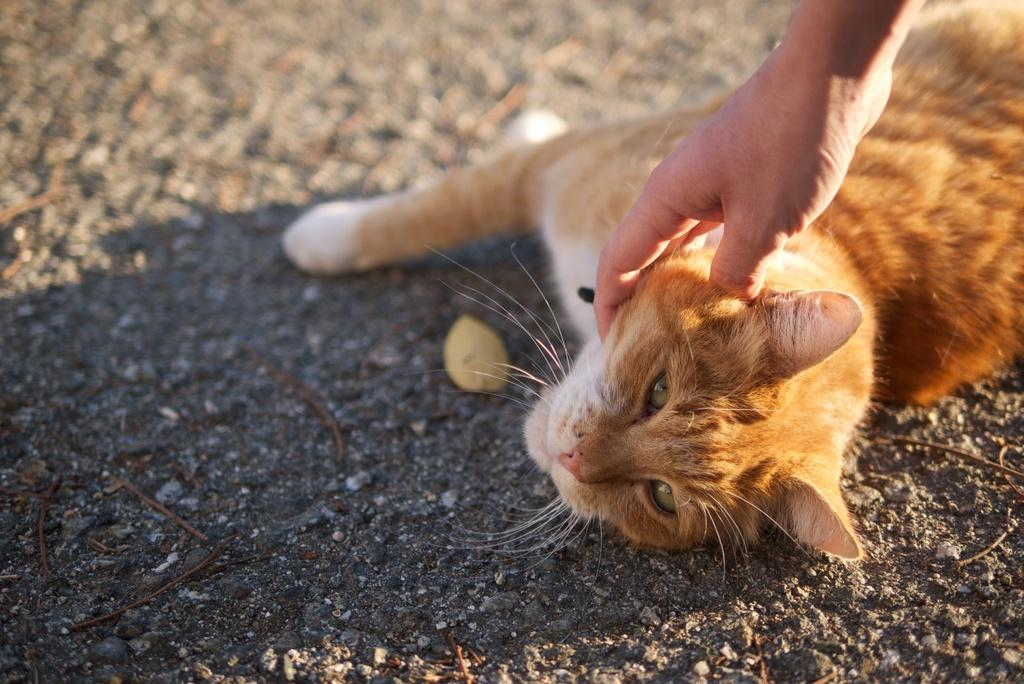What type of animal is in the image? There is a cat in the image. Can you describe the appearance of the cat? The cat is brown and white in color. What is the cat doing in the image? The cat is resting on the ground. What else can be seen in the image? There is a person's hand in the image. What is the person's hand doing? The person's hand is pampering the cat. What type of vegetable is being used as a toy for the cat in the image? There is no vegetable present in the image, and the cat is not playing with any toys. Are there any mice visible in the image? There are no mice present in the image. 